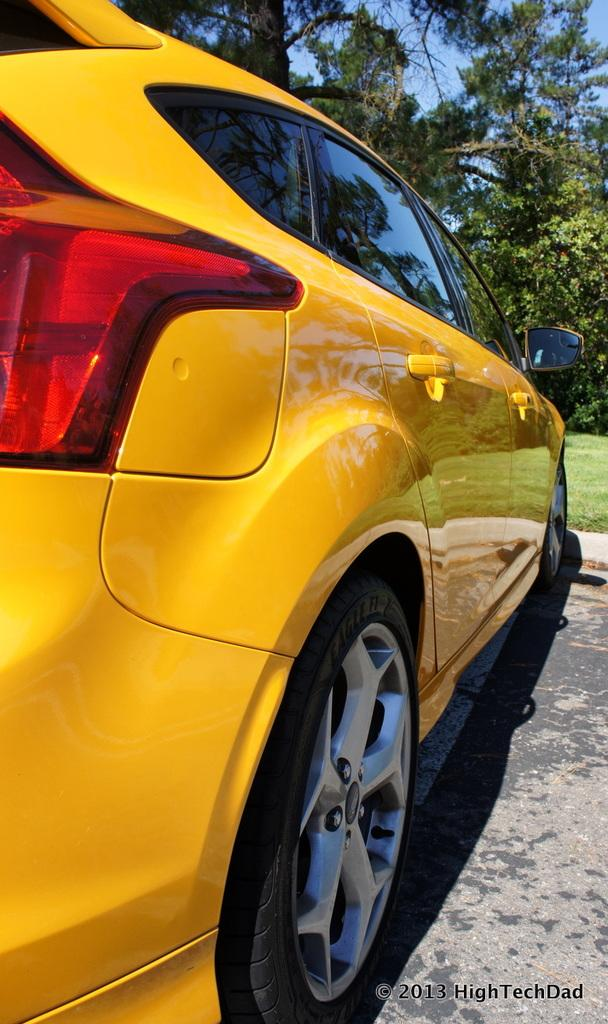What is the main subject of the image? There is a car on the road in the image. Where is the car located? The car is on the road in the image. What can be seen in the background of the image? There are trees and the sky visible in the background of the image. Is there any text present in the image? Yes, there is some text in the bottom right corner of the image. Can you see a tent in the image? No, there is no tent present in the image. What type of crack is visible on the car's windshield in the image? There is no crack visible on the car's windshield in the image. 